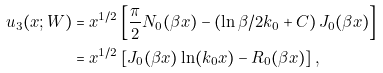<formula> <loc_0><loc_0><loc_500><loc_500>u _ { 3 } ( x ; W ) & = x ^ { 1 / 2 } \left [ \frac { \pi } { 2 } N _ { 0 } ( \beta x ) - \left ( \ln \beta / 2 k _ { 0 } + C \right ) J _ { 0 } ( \beta x ) \right ] \\ & = x ^ { 1 / 2 } \left [ J _ { 0 } ( \beta x ) \ln ( k _ { 0 } x ) - R _ { 0 } ( \beta x ) \right ] ,</formula> 